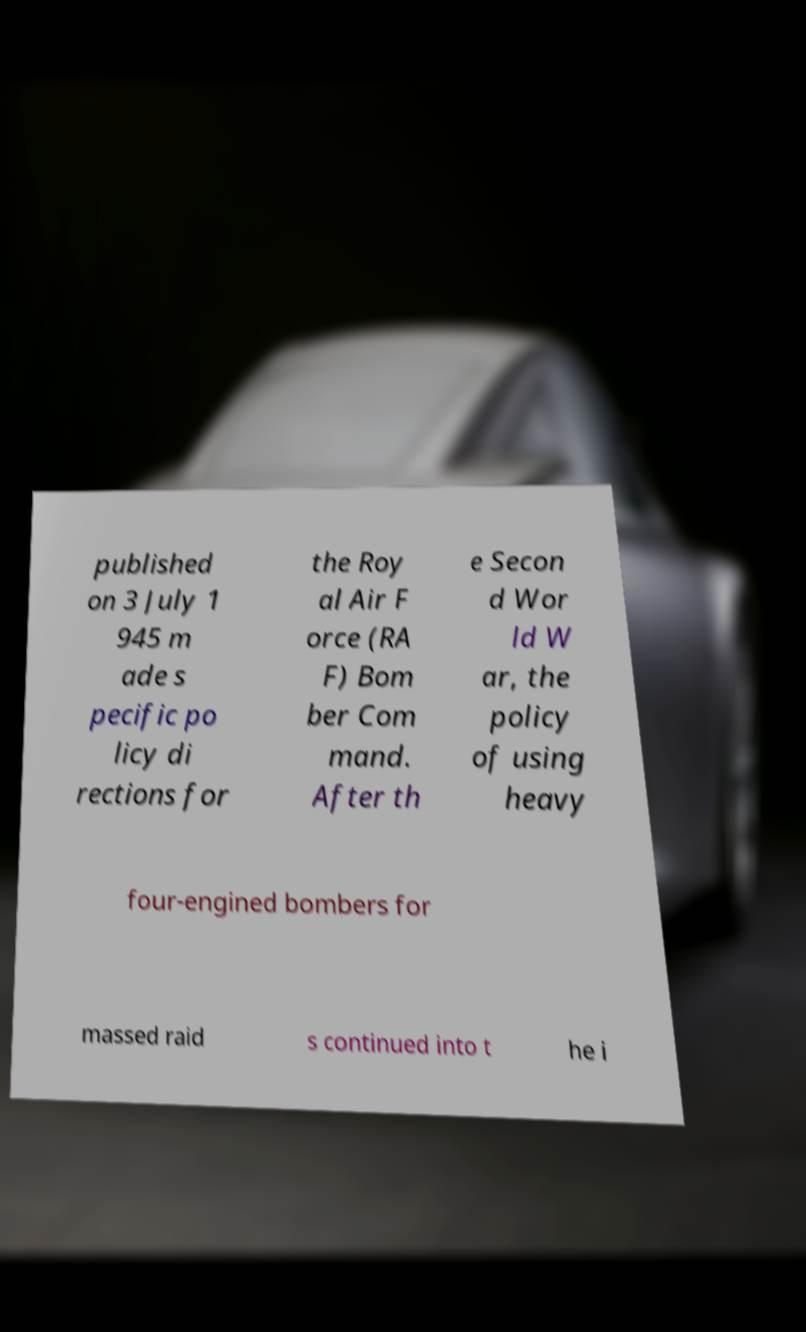Please read and relay the text visible in this image. What does it say? published on 3 July 1 945 m ade s pecific po licy di rections for the Roy al Air F orce (RA F) Bom ber Com mand. After th e Secon d Wor ld W ar, the policy of using heavy four-engined bombers for massed raid s continued into t he i 